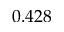Convert formula to latex. <formula><loc_0><loc_0><loc_500><loc_500>0 . 4 2 8</formula> 